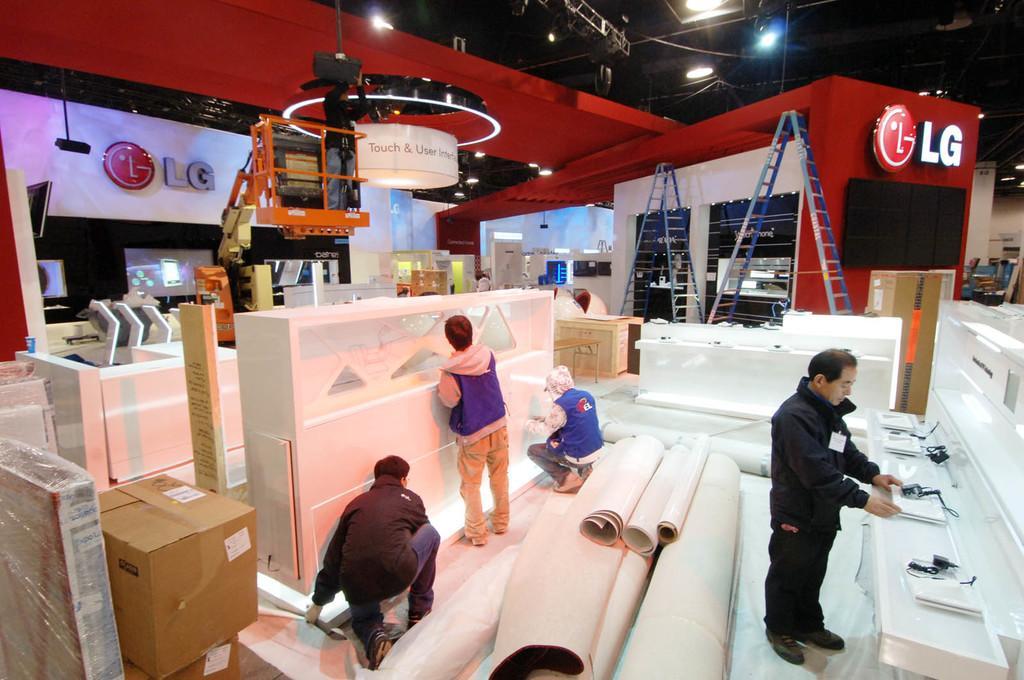Can you describe this image briefly? This image consists of many persons. On the right, there is a man wearing a black jacket is standing. In the middle, there are sheets roles. On the left, there are boxes. In the front, we can see a man standing on a crane. On the right, there are ladders. At the top, there is a roof along with the lights. 